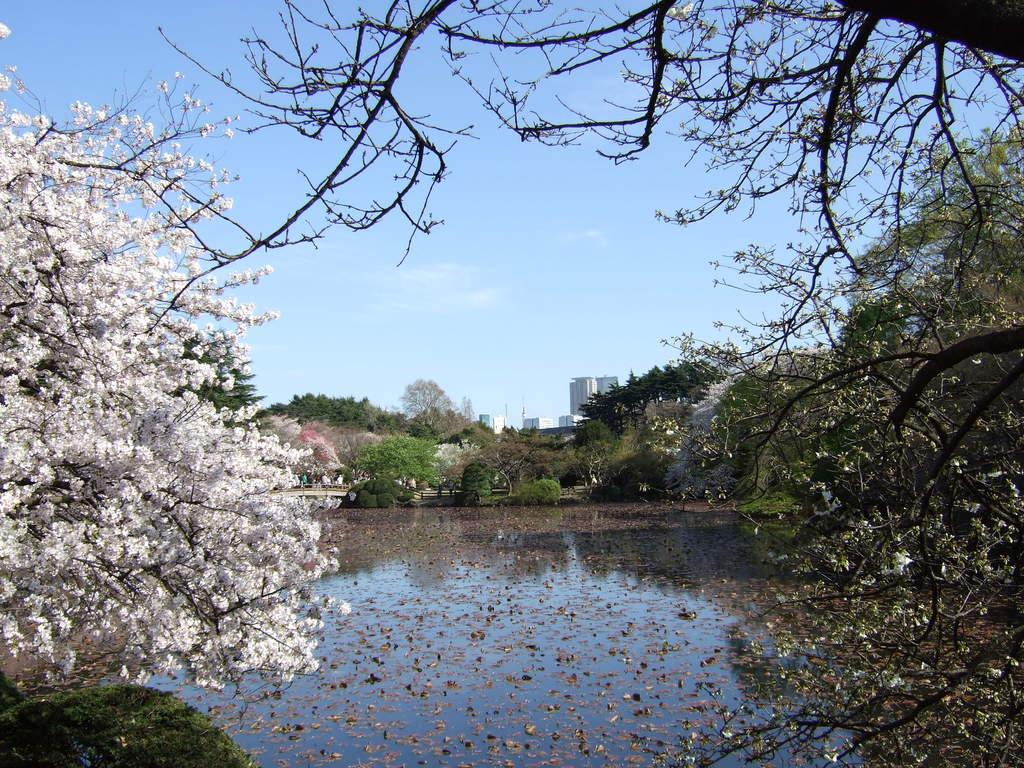What is the primary element in the image? There is water in the image. What type of vegetation can be seen in the image? There are trees with flowers in the image. What type of man-made structures are present in the image? There are buildings in the image. What type of architectural feature is present in the image? There is a bridge in the image. Who or what is on the bridge? People are present on the bridge. What is visible in the background of the image? The sky is visible in the background of the image. What time of day is depicted in the image based on the hour? The provided facts do not mention a specific time of day or hour, so it cannot be determined from the image. 